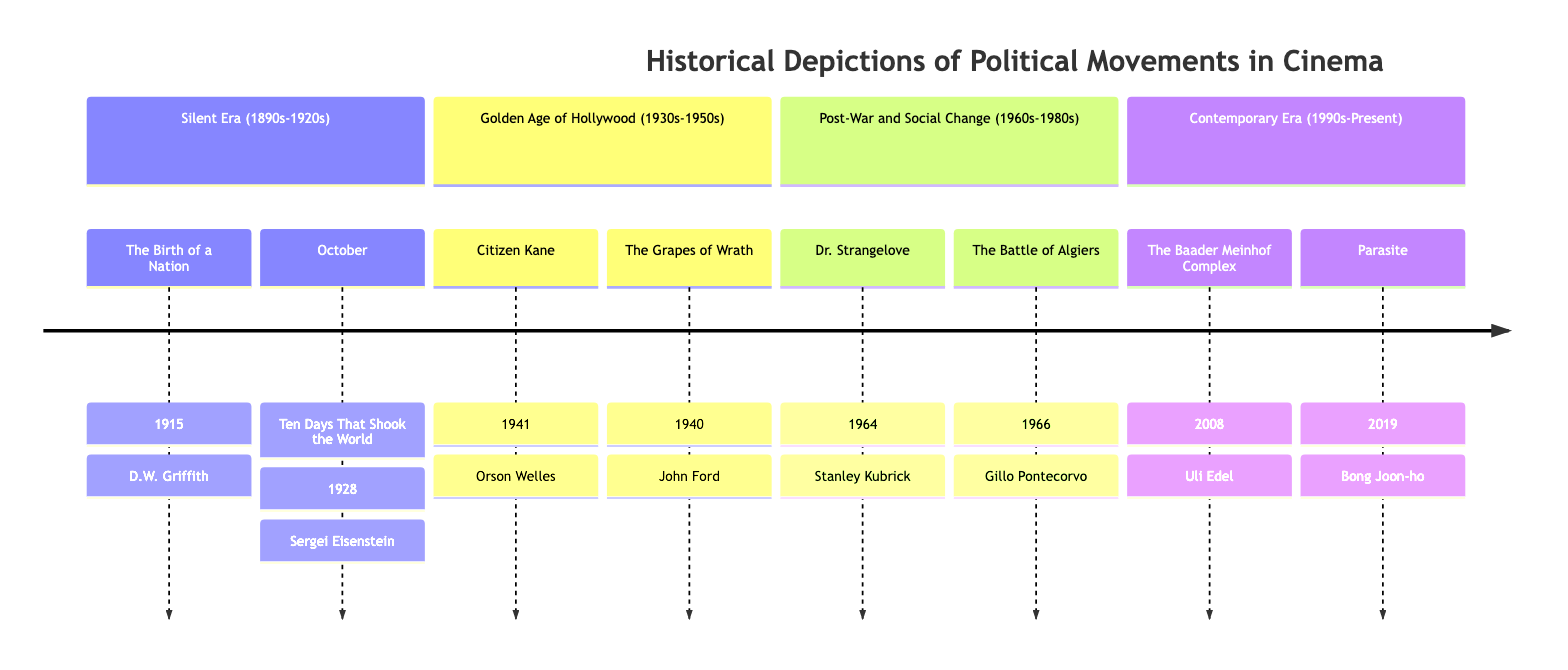What film directed by D.W. Griffith was released in 1915? The diagram lists "The Birth of a Nation" under the Silent Era and indicates that it was directed by D.W. Griffith in 1915.
Answer: The Birth of a Nation How many films are depicted in the Golden Age of Hollywood section? The timeline shows two films listed under the Golden Age of Hollywood era, which are "Citizen Kane" and "The Grapes of Wrath."
Answer: 2 Which film released in 1964 has a satirical tone? The diagram identifies "Dr. Strangelove," released in 1964, as having a satirical tone and is in the Post-War and Social Change section.
Answer: Dr. Strangelove What narrative technique is associated with "October: Ten Days That Shook the World"? According to the timeline, "October: Ten Days That Shook the World" utilizes "Montage sequences," which is one of its narrative techniques mentioned.
Answer: Montage sequences Which film from the Contemporary Era has been criticized for glamorizing terrorism? The timeline specifies that "The Baader Meinhof Complex," released in 2008, has been critically examined for glamorizing terrorism.
Answer: The Baader Meinhof Complex What is the public reception of "Citizen Kane"? The diagram states that "Citizen Kane" is positively recognized for revolutionizing narrative structure but had a "Moderate initial box office reception" as a negative aspect.
Answer: Revolutionized narrative structure, Moderate initial box office reception Which director is associated with the film "The Grapes of Wrath"? The timeline clearly indicates that "The Grapes of Wrath" was directed by John Ford, as noted under the Golden Age of Hollywood section.
Answer: John Ford What years does the Silent Era cover? Referring to the timeline, the Silent Era spans from the 1890s to the 1920s, which is explicitly stated in the diagram.
Answer: 1890s-1920s 